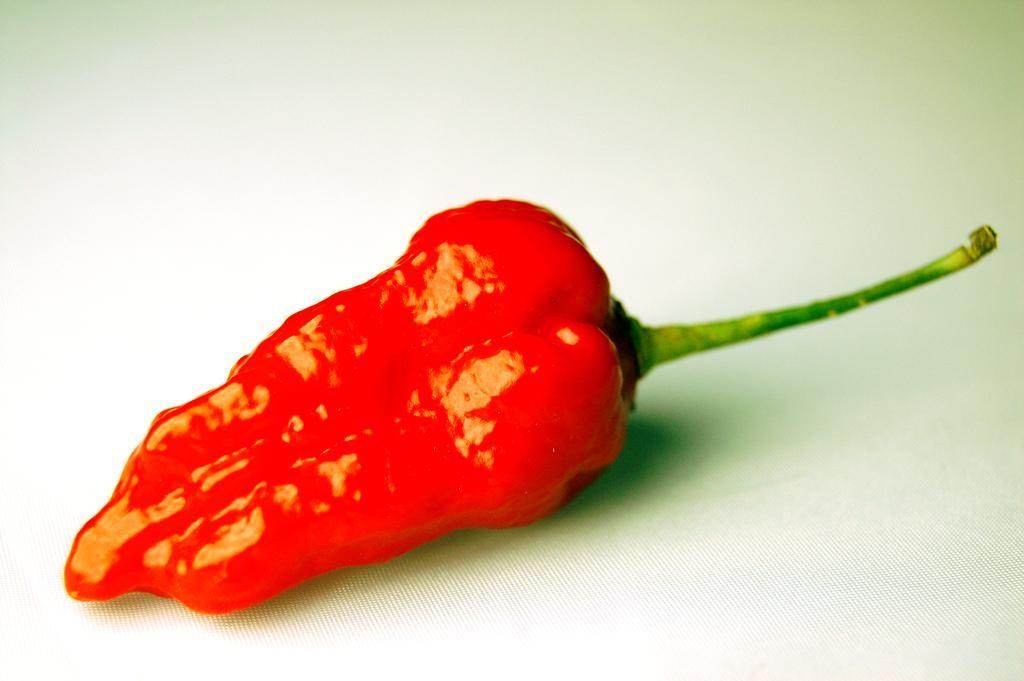How would you summarize this image in a sentence or two? In this picture there is a red chilies on a white surface. 